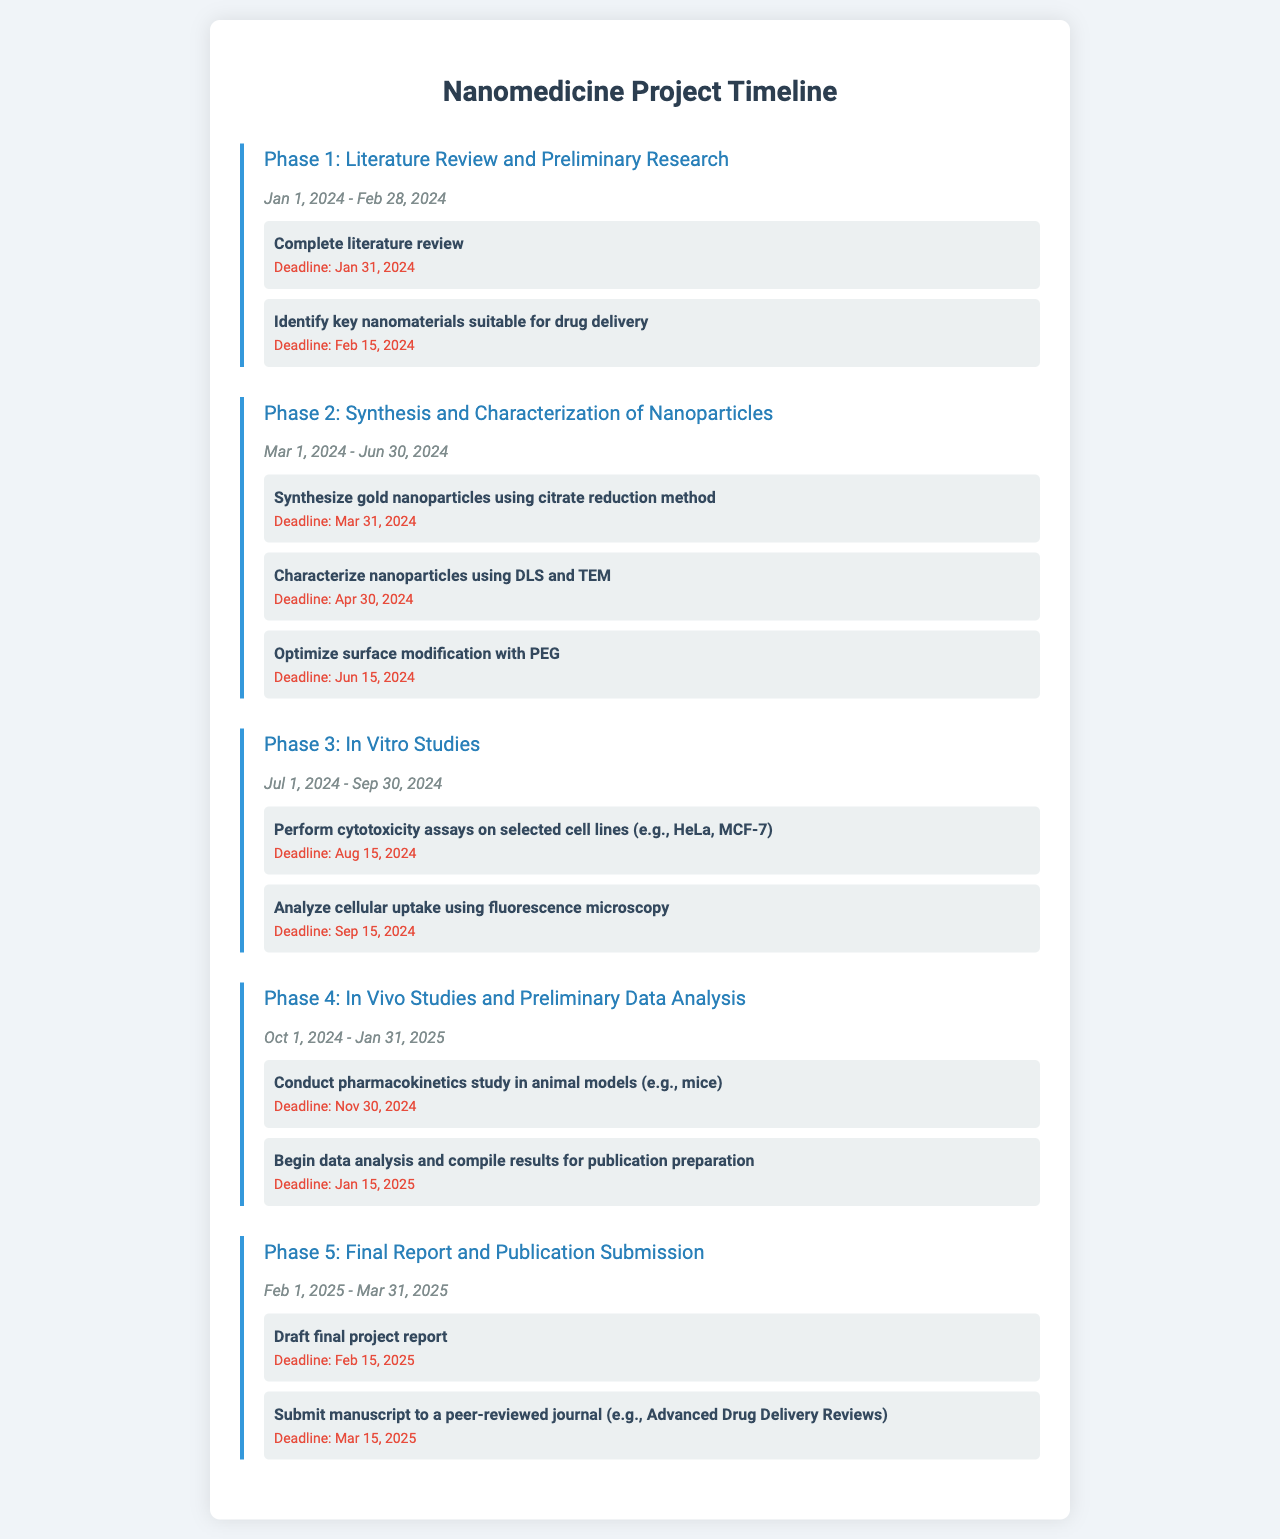What are the start and end dates for Phase 1? Phase 1 covers the period from January 1, 2024 to February 28, 2024.
Answer: January 1, 2024 - February 28, 2024 What is the first milestone in Phase 2? The first milestone in Phase 2 is to synthesize gold nanoparticles using the citrate reduction method.
Answer: Synthesize gold nanoparticles using citrate reduction method What is the deadline for the cytotoxicity assays in Phase 3? The cytotoxicity assays must be completed by August 15, 2024.
Answer: August 15, 2024 How many milestones are there in Phase 4? Phase 4 consists of two milestones.
Answer: Two What is the title of the document? The title of the document is displayed at the top and indicates the purpose of the content.
Answer: Nanomedicine Project Timeline Which phase includes in vivo studies? In vivo studies are included in Phase 4.
Answer: Phase 4 What is the final deadline for manuscript submission in Phase 5? The manuscript must be submitted by March 15, 2025.
Answer: March 15, 2025 When does the literature review need to be completed? The literature review must be completed by January 31, 2024.
Answer: January 31, 2024 What is the primary focus of Phase 3? The primary focus of Phase 3 is conducting in vitro studies.
Answer: In Vitro Studies 